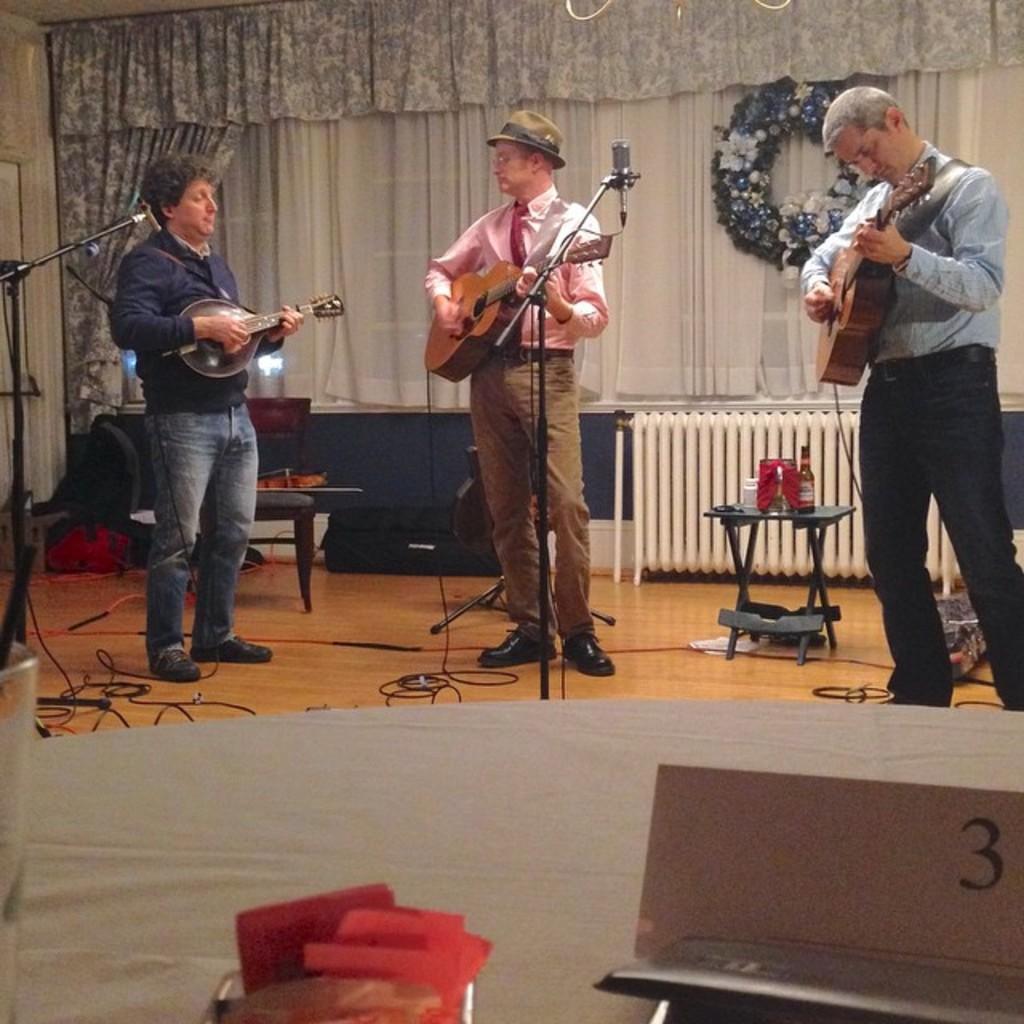How would you summarize this image in a sentence or two? It seems to be the image is inside the room. In the image there are three men's standing and playing their musical instruments in front of a microphone. On right side we can see a table, on table there are bottles and a jar and we can also see another table in middle. On that table there is a food and a glass in background there we can see a white color curtain on left side there is a white color door. 